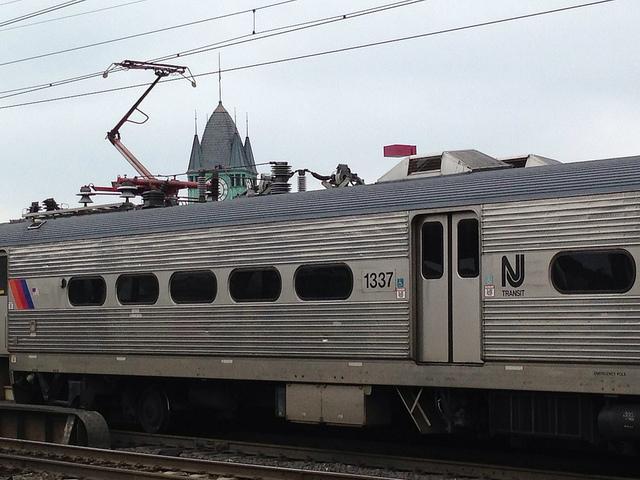What kind of building is in the background?
Answer briefly. Church. How many train windows are visible?
Answer briefly. 8. Where is the train at?
Be succinct. Station. What is the train number?
Keep it brief. 1337. 